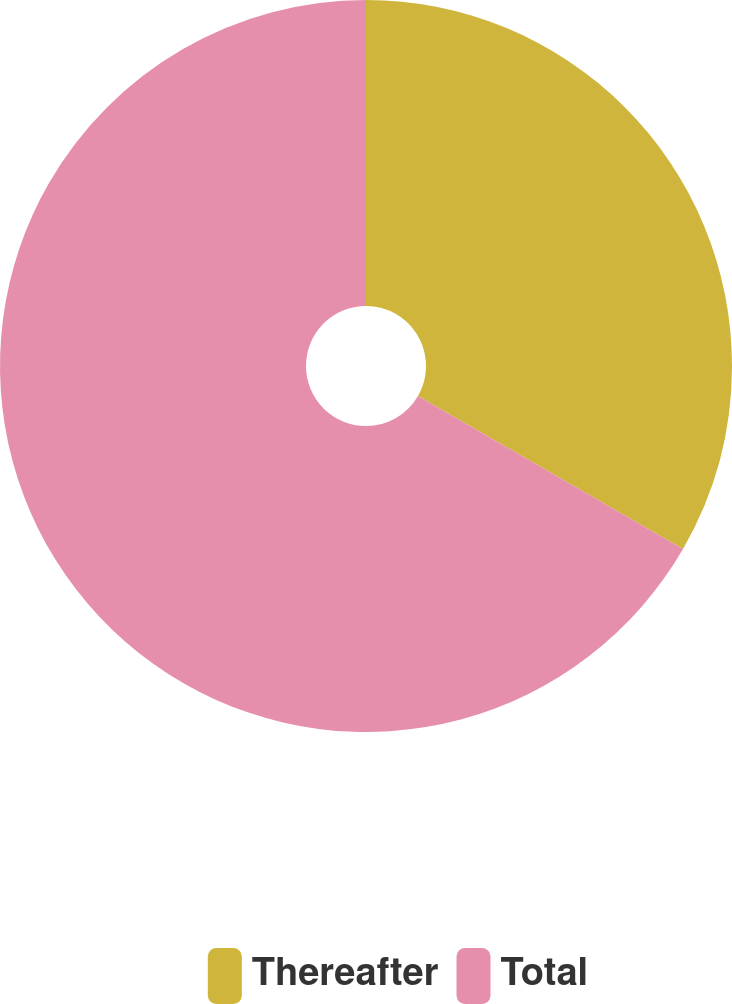Convert chart to OTSL. <chart><loc_0><loc_0><loc_500><loc_500><pie_chart><fcel>Thereafter<fcel>Total<nl><fcel>33.33%<fcel>66.67%<nl></chart> 